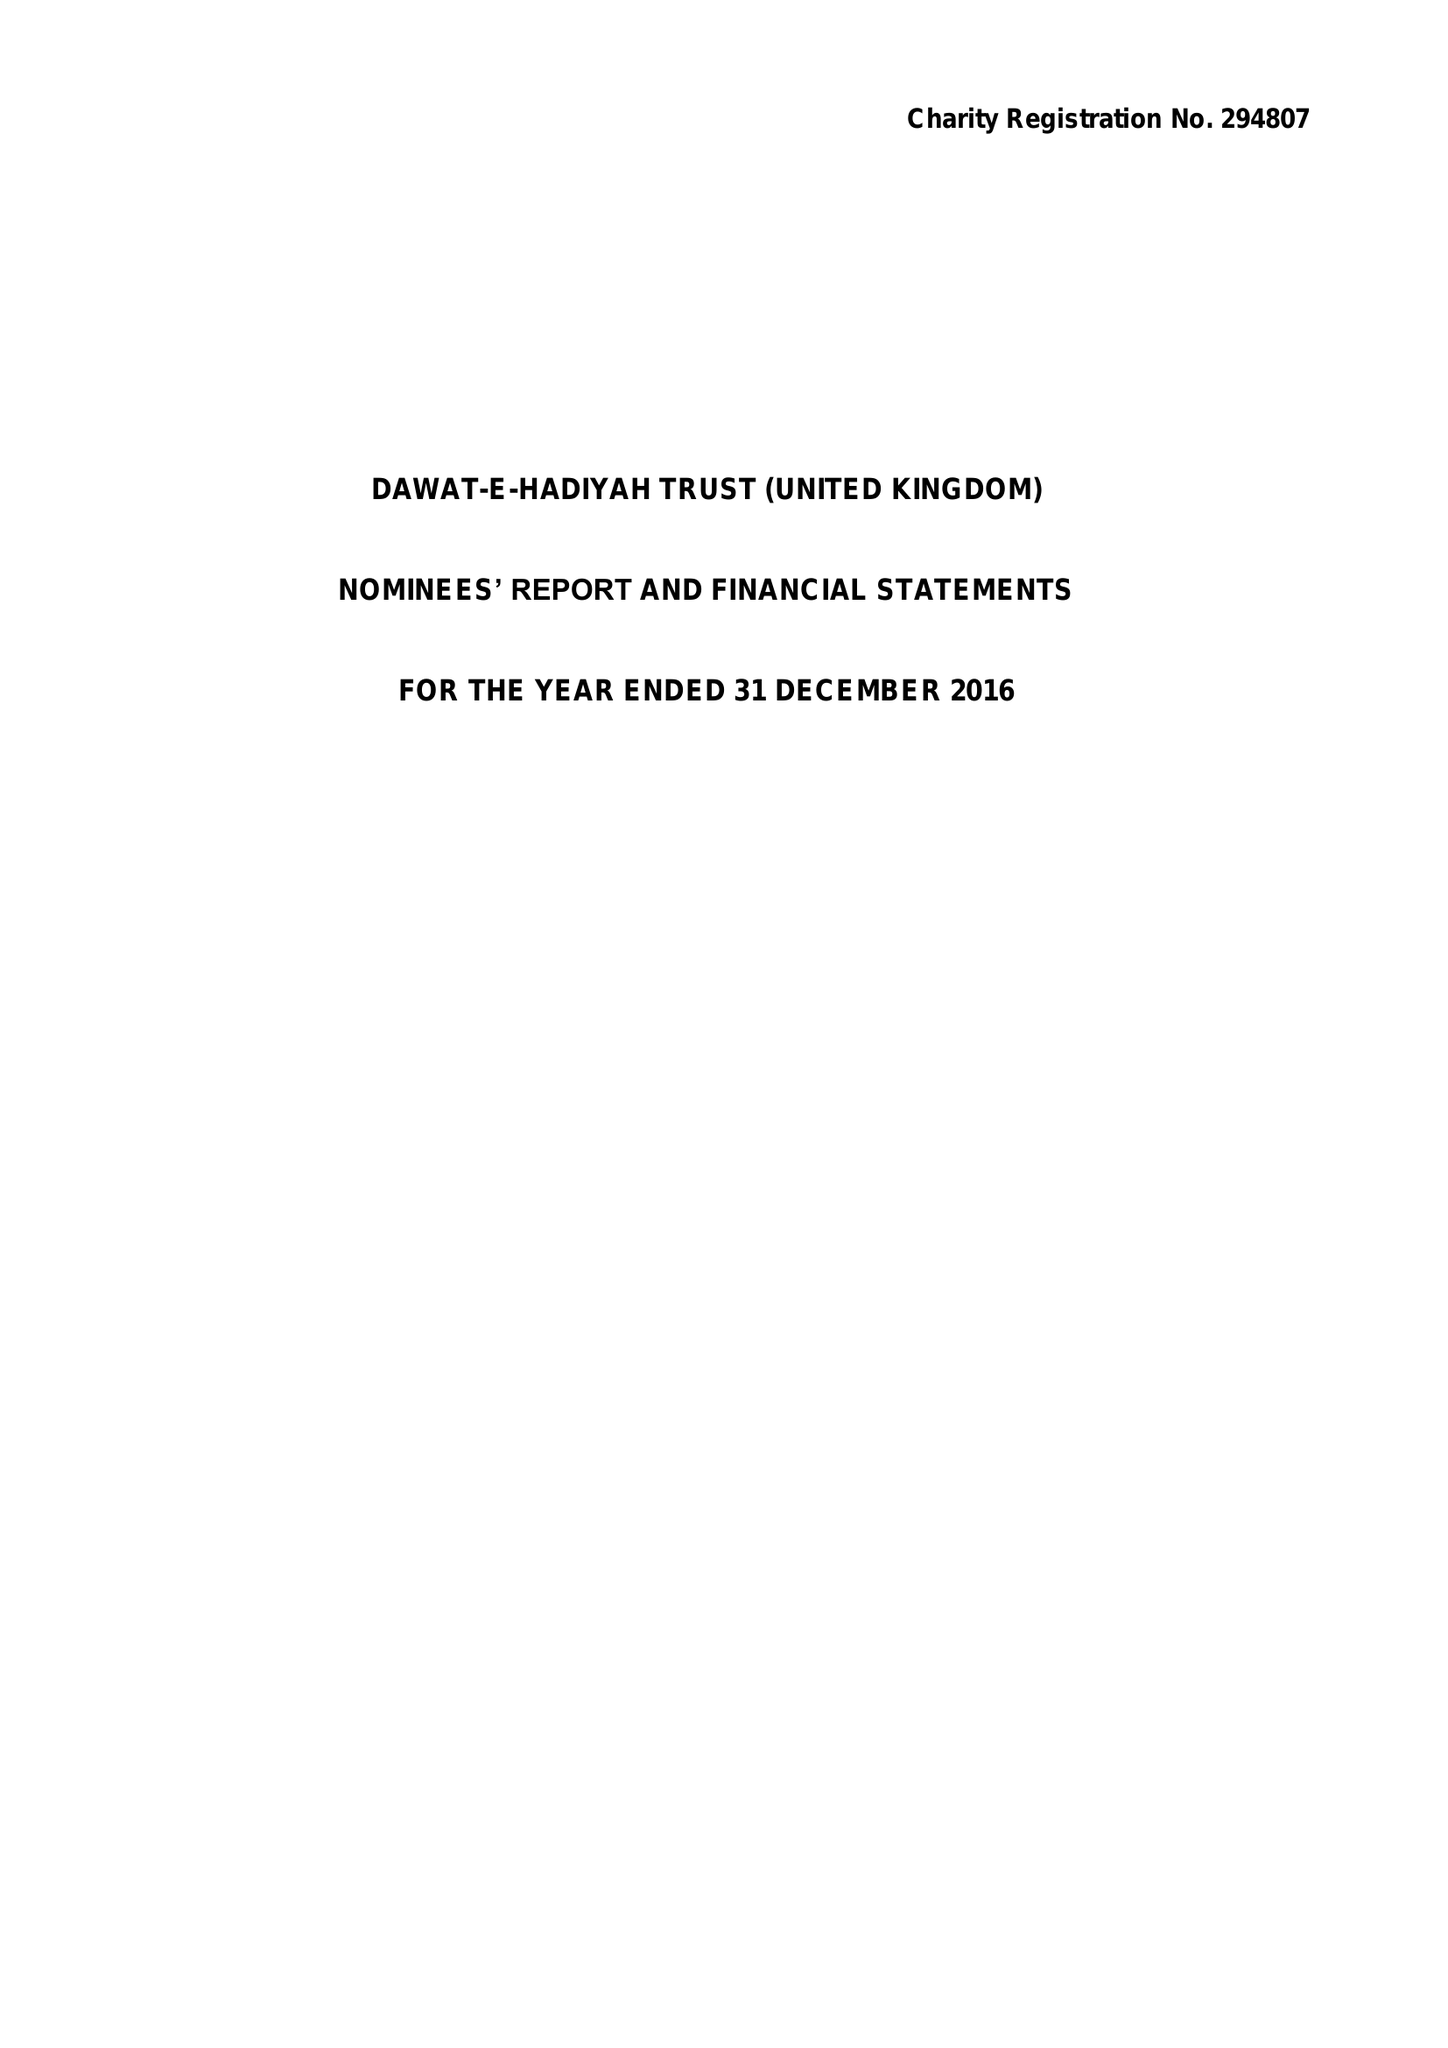What is the value for the address__postcode?
Answer the question using a single word or phrase. UB5 6AG 